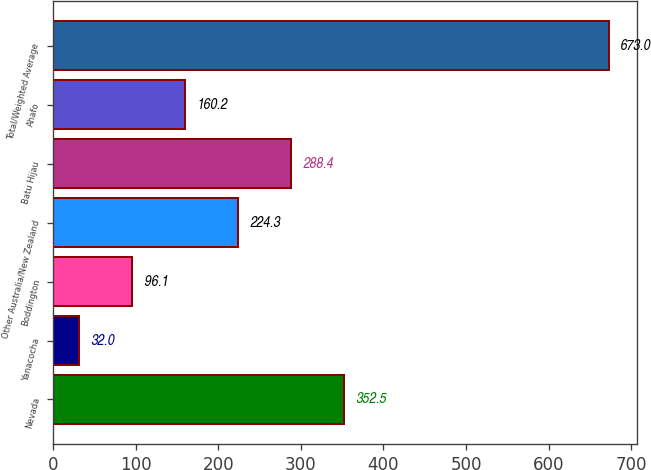Convert chart. <chart><loc_0><loc_0><loc_500><loc_500><bar_chart><fcel>Nevada<fcel>Yanacocha<fcel>Boddington<fcel>Other Australia/New Zealand<fcel>Batu Hijau<fcel>Ahafo<fcel>Total/Weighted Average<nl><fcel>352.5<fcel>32<fcel>96.1<fcel>224.3<fcel>288.4<fcel>160.2<fcel>673<nl></chart> 